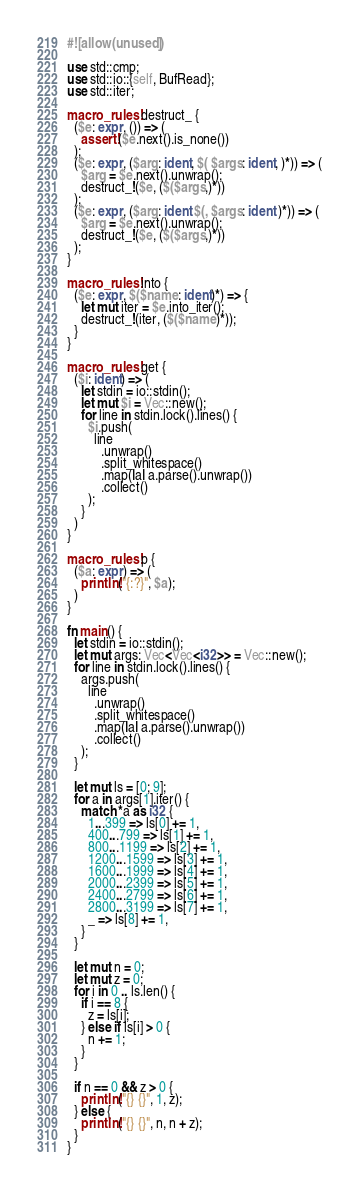<code> <loc_0><loc_0><loc_500><loc_500><_Rust_>
#![allow(unused)]

use std::cmp;
use std::io::{self, BufRead};
use std::iter;

macro_rules! destruct_ {
  ($e: expr, ()) => (
    assert!($e.next().is_none())
  );
  ($e: expr, ($arg: ident, $( $args: ident, )*)) => (
    $arg = $e.next().unwrap();
    destruct_!($e, ($($args,)*))
  );
  ($e: expr, ($arg: ident $(, $args: ident )*)) => (
    $arg = $e.next().unwrap();
    destruct_!($e, ($($args,)*))
  );
}

macro_rules! into {
  ($e: expr, $($name: ident)*) => {
    let mut iter = $e.into_iter();
    destruct_!(iter, ($($name)*));
  }
}

macro_rules! get {
  ($i: ident) => (
    let stdin = io::stdin();
    let mut $i = Vec::new();
    for line in stdin.lock().lines() {
      $i.push(
        line
          .unwrap()
          .split_whitespace()
          .map(|a| a.parse().unwrap())
          .collect()
      );
    }
  )
}

macro_rules! p {
  ($a: expr) => (
    println!("{:?}", $a);
  )
}

fn main() {
  let stdin = io::stdin();
  let mut args: Vec<Vec<i32>> = Vec::new();
  for line in stdin.lock().lines() {
    args.push(
      line
        .unwrap()
        .split_whitespace()
        .map(|a| a.parse().unwrap())
        .collect()
    );
  }

  let mut ls = [0; 9];
  for a in args[1].iter() {
    match *a as i32 {
      1...399 => ls[0] += 1,
      400...799 => ls[1] += 1,
      800...1199 => ls[2] += 1,
      1200...1599 => ls[3] += 1,
      1600...1999 => ls[4] += 1,
      2000...2399 => ls[5] += 1,
      2400...2799 => ls[6] += 1,
      2800...3199 => ls[7] += 1,
      _ => ls[8] += 1,
    }
  }

  let mut n = 0;
  let mut z = 0;
  for i in 0 .. ls.len() {
    if i == 8 {
      z = ls[i];
    } else if ls[i] > 0 {
      n += 1;
    }
  }

  if n == 0 && z > 0 {
    println!("{} {}", 1, z);
  } else {
    println!("{} {}", n, n + z);
  }
}
</code> 